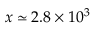Convert formula to latex. <formula><loc_0><loc_0><loc_500><loc_500>x \simeq 2 . 8 \times 1 0 ^ { 3 }</formula> 